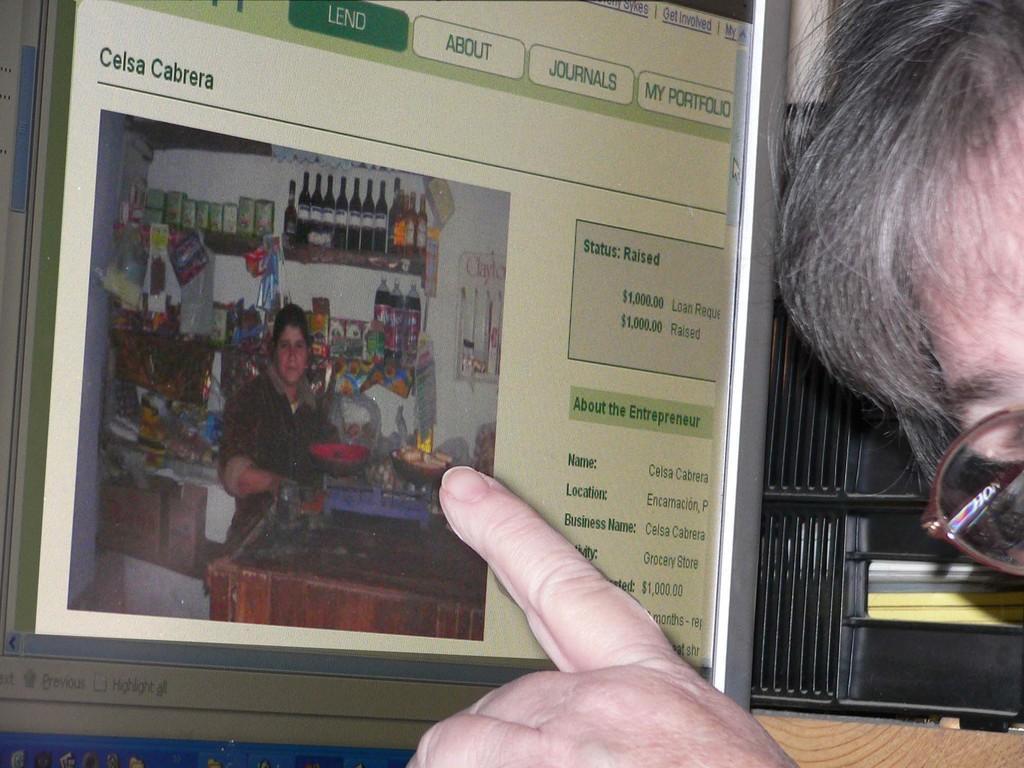In one or two sentences, can you explain what this image depicts? On the right we can see a person who is wearing spectacle and he is putting his finger on this screen. On the screen there is a woman who is standing near the table. Here we can see box, bottles, papers, plastic covers, pan and other objects. On the bottom right corner there is a desk. 